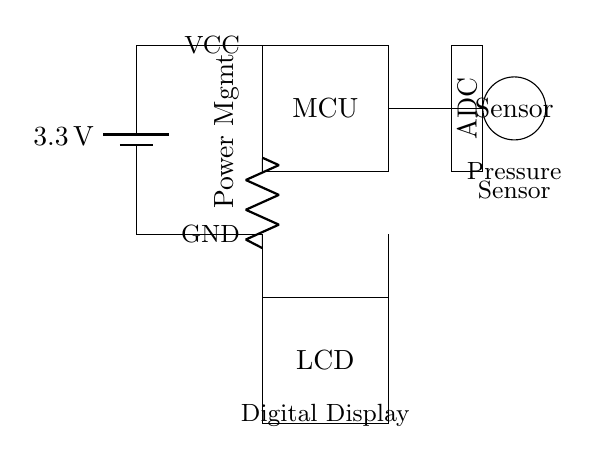What is the power supply voltage? The power supply voltage is indicated in the diagram next to the battery symbol. It shows that the circuit operates at 3.3 volts.
Answer: 3.3 volts What component is connected to the pressure sensor? The pressure sensor connects to the ADC (Analog to Digital Converter) as shown by the line linking the sensor to the ADC component in the circuit.
Answer: ADC What is the function of the microcontroller in this circuit? The microcontroller processes the signals received from the pressure sensor and controls the LCD display. This is inferred from its central position and connections to both the pressure sensor and the LCD.
Answer: Process signals How does the power management component affect the circuit? The power management component controls the voltage distribution throughout the circuit, ensuring that the microcontroller and other components receive the correct voltages for operation. It connects from the power supply to the microcontroller.
Answer: Distributes voltage What type of display is used to show the blood pressure readings? The display type is specified in the diagram where it is labeled as an LCD, indicating the use of a Liquid Crystal Display for the visual output.
Answer: LCD Which components are responsible for power conversion in this circuit? The components involved in power conversion are the battery and the power management unit, as the battery supplies power and the power management ensures it is properly regulated for the MCU and other devices.
Answer: Battery and Power Management 